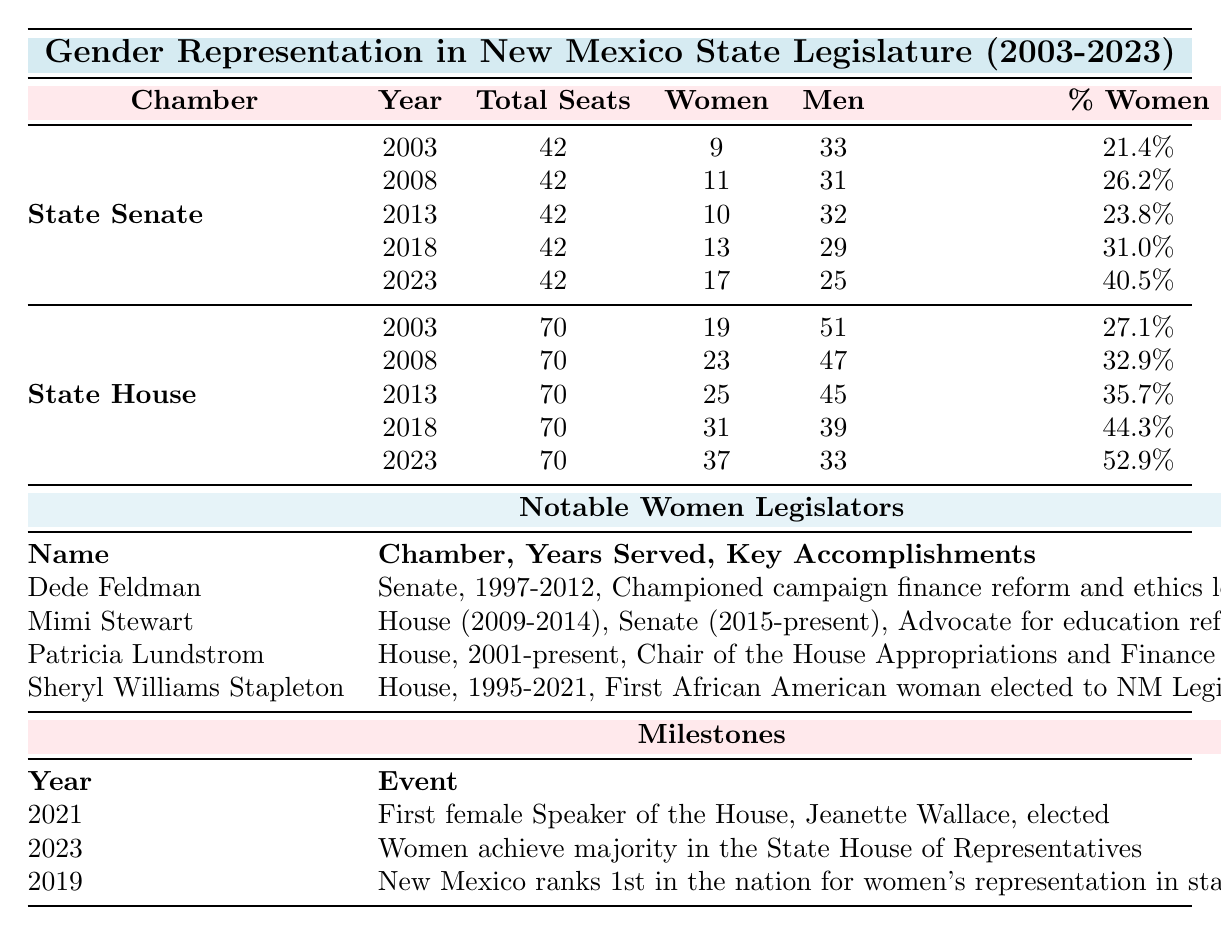What was the percentage of women in the State Senate in 2023? The table indicates that in 2023, the percentage of women in the State Senate was listed as 40.5%.
Answer: 40.5% How many women served in the State House of Representatives in 2018? According to the table, there were 31 women serving in the State House of Representatives in 2018.
Answer: 31 Did New Mexico achieve a majority of women in the State House of Representatives by 2023? Yes, the table states that in 2023, women achieved a majority in the State House of Representatives, with 37 women out of 70 total seats.
Answer: Yes What is the difference in the number of women in the State Senate between 2008 and 2023? In 2008, there were 11 women in the State Senate, and in 2023, there were 17. The difference is 17 - 11 = 6.
Answer: 6 What is the average percentage of women in the State House of Representatives over the years presented? To find the average percentage of women in the State House from 2003 to 2023: (27.1 + 32.9 + 35.7 + 44.3 + 52.9) / 5 = 38.6.
Answer: 38.6 Which year saw New Mexico rank 1st in the nation for women's representation in state legislature? The table clearly states that New Mexico ranked 1st in the nation for women's representation in the state legislature in 2019.
Answer: 2019 What was the total number of women serving in both chambers combined in 2023? In 2023, there were 17 women in the State Senate and 37 in the State House. The total number of women is 17 + 37 = 54.
Answer: 54 How many notable women legislators served in the House? From the table, there are three notable women legislators listed who served in the House: Mimi Stewart, Patricia Lundstrom, and Sheryl Williams Stapleton.
Answer: 3 What percentage of women in the State House was recorded in 2008, and how does it compare to the percentage in 2018? The percentage of women in the State House in 2008 was 32.9%, and in 2018 it was 44.3%. The difference between them is 44.3% - 32.9% = 11.4%, indicating growth in women's representation.
Answer: 11.4% In which year was the first female Speaker of the House elected? According to the milestones table, the first female Speaker of the House, Jeanette Wallace, was elected in 2021.
Answer: 2021 